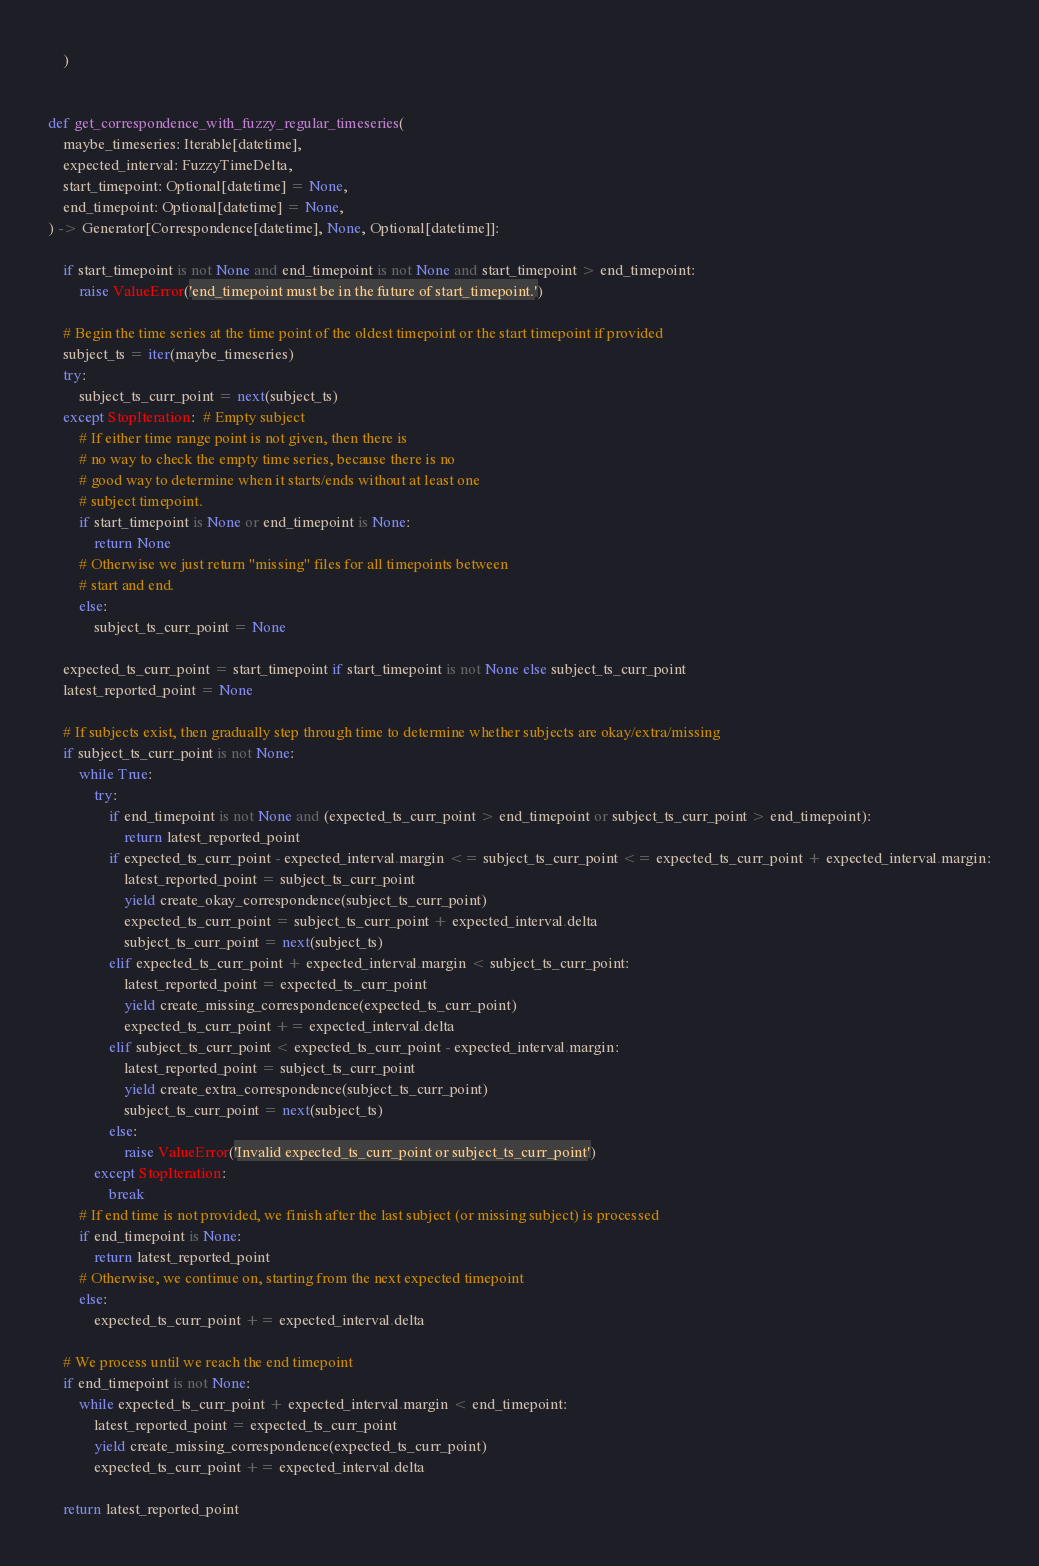<code> <loc_0><loc_0><loc_500><loc_500><_Python_>    )


def get_correspondence_with_fuzzy_regular_timeseries(
    maybe_timeseries: Iterable[datetime],
    expected_interval: FuzzyTimeDelta,
    start_timepoint: Optional[datetime] = None,
    end_timepoint: Optional[datetime] = None,
) -> Generator[Correspondence[datetime], None, Optional[datetime]]:

    if start_timepoint is not None and end_timepoint is not None and start_timepoint > end_timepoint:
        raise ValueError('end_timepoint must be in the future of start_timepoint.')

    # Begin the time series at the time point of the oldest timepoint or the start timepoint if provided
    subject_ts = iter(maybe_timeseries)
    try:
        subject_ts_curr_point = next(subject_ts)
    except StopIteration:  # Empty subject
        # If either time range point is not given, then there is
        # no way to check the empty time series, because there is no
        # good way to determine when it starts/ends without at least one
        # subject timepoint.
        if start_timepoint is None or end_timepoint is None:
            return None
        # Otherwise we just return "missing" files for all timepoints between
        # start and end.
        else:
            subject_ts_curr_point = None

    expected_ts_curr_point = start_timepoint if start_timepoint is not None else subject_ts_curr_point
    latest_reported_point = None

    # If subjects exist, then gradually step through time to determine whether subjects are okay/extra/missing
    if subject_ts_curr_point is not None:
        while True:
            try:
                if end_timepoint is not None and (expected_ts_curr_point > end_timepoint or subject_ts_curr_point > end_timepoint):
                    return latest_reported_point
                if expected_ts_curr_point - expected_interval.margin <= subject_ts_curr_point <= expected_ts_curr_point + expected_interval.margin:
                    latest_reported_point = subject_ts_curr_point
                    yield create_okay_correspondence(subject_ts_curr_point)
                    expected_ts_curr_point = subject_ts_curr_point + expected_interval.delta
                    subject_ts_curr_point = next(subject_ts)
                elif expected_ts_curr_point + expected_interval.margin < subject_ts_curr_point:
                    latest_reported_point = expected_ts_curr_point
                    yield create_missing_correspondence(expected_ts_curr_point)
                    expected_ts_curr_point += expected_interval.delta
                elif subject_ts_curr_point < expected_ts_curr_point - expected_interval.margin:
                    latest_reported_point = subject_ts_curr_point
                    yield create_extra_correspondence(subject_ts_curr_point)
                    subject_ts_curr_point = next(subject_ts)
                else:
                    raise ValueError('Invalid expected_ts_curr_point or subject_ts_curr_point')
            except StopIteration:
                break
        # If end time is not provided, we finish after the last subject (or missing subject) is processed
        if end_timepoint is None:
            return latest_reported_point
        # Otherwise, we continue on, starting from the next expected timepoint
        else:
            expected_ts_curr_point += expected_interval.delta

    # We process until we reach the end timepoint
    if end_timepoint is not None:
        while expected_ts_curr_point + expected_interval.margin < end_timepoint:
            latest_reported_point = expected_ts_curr_point
            yield create_missing_correspondence(expected_ts_curr_point)
            expected_ts_curr_point += expected_interval.delta
    
    return latest_reported_point</code> 